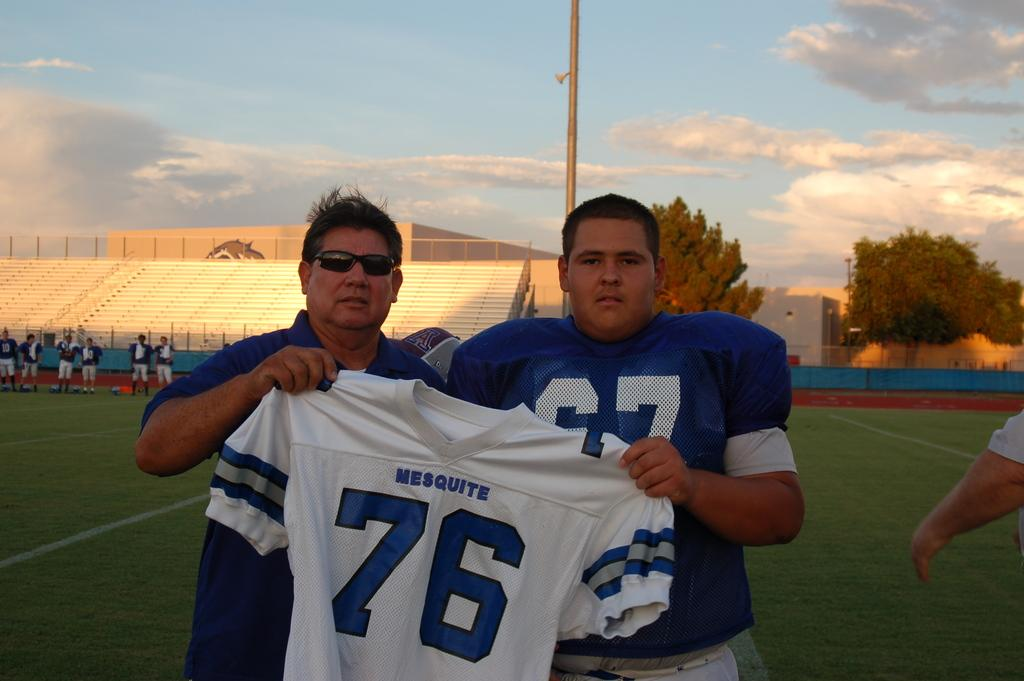<image>
Render a clear and concise summary of the photo. The two men are holding a white Mesquite #76 jersey. 